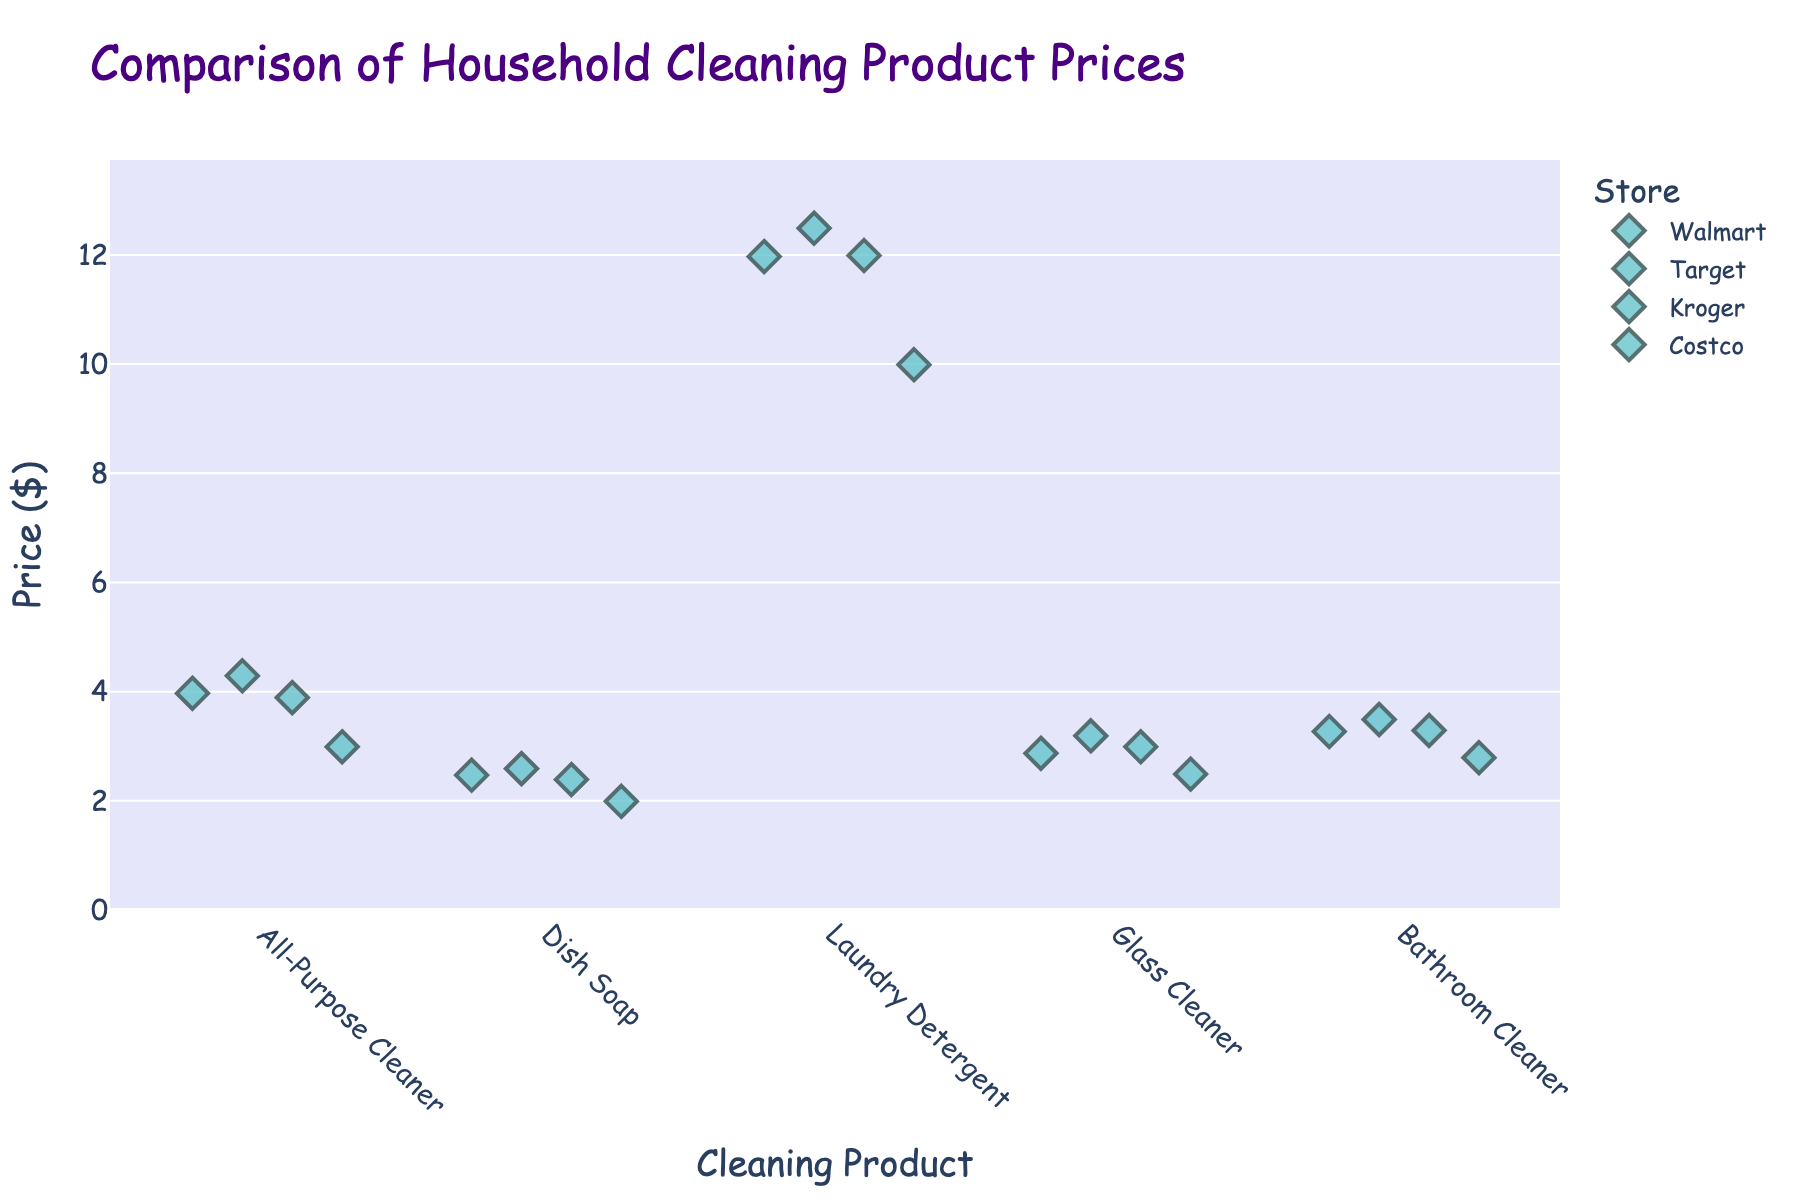How many products are compared in the figure? The X-axis of the strip plot shows different products being compared. Each unique product name corresponds to a different category on the axis. By counting them, we see there are five categories: All-Purpose Cleaner, Dish Soap, Laundry Detergent, Glass Cleaner, and Bathroom Cleaner.
Answer: 5 Which store offers the cheapest price for Laundry Detergent? To find the cheapest price for Laundry Detergent, look at the prices for Laundry Detergent across all stores. Walmart offers it at $11.97, Target at $12.49, Kroger at $11.99, and Costco at $9.99. The cheapest price is $9.99 at Costco.
Answer: Costco Which product has the highest price for any store, and what is that price? For each product, check the maximum price listed at any store. The prices for All-Purpose Cleaner range from $2.99 to $4.29, Dish Soap from $1.99 to $2.59, Laundry Detergent from $9.99 to $12.49, Glass Cleaner from $2.49 to $3.19, and Bathroom Cleaner from $2.79 to $3.49. The highest price is $12.49 for Laundry Detergent at Target.
Answer: Laundry Detergent; $12.49 What is the price range for Dish Soap across the different stores? To determine the price range, find the minimum and maximum prices for Dish Soap. The prices are $2.47 at Walmart, $2.59 at Target, $2.39 at Kroger, and $1.99 at Costco. The range is from $1.99 to $2.59, making it $2.59 - $1.99 = $0.60.
Answer: $0.60 Compare the prices for Bathroom Cleaner between Walmart and Target. Which store is more expensive and by how much? Find the prices of Bathroom Cleaner at Walmart and Target. Walmart offers it at $3.27 and Target at $3.49. The difference is $3.49 - $3.27 = $0.22. Target is more expensive by $0.22.
Answer: Target; $0.22 Which store consistently offers the cheapest prices for most products? By reviewing the prices for each product across all stores, it's evident that Costco offers the lowest prices in 4 out of 5 categories: All-Purpose Cleaner, Dish Soap, Laundry Detergent, Glass Cleaner, and Bathroom Cleaner.
Answer: Costco For those products where Costco is not the cheapest, which store offers a lower price? For All-Purpose Cleaner, Costco is the cheapest. For Dish Soap, Costco is the cheapest. For Laundry Detergent, Walmart is $11.97 (more expensive than Costco's $9.99). For Glass Cleaner, no store has a price lower than Costco’s. For Bathroom Cleaner, no store offers a cheaper price. The only exception where Costco does not have the cheapest price is Laundry Detergent at Walmart.
Answer: Walmart What is the average price of Glass Cleaner across all stores? The prices of Glass Cleaner are $2.87 at Walmart, $3.19 at Target, $2.99 at Kroger, and $2.49 at Costco. Sum these prices ($2.87 + $3.19 + $2.99 + $2.49 = $11.54) and divide by the number of stores (4). The average price is $11.54 / 4 = $2.885.
Answer: $2.885 What product demonstrates the smallest price difference across stores? Determine the price difference for each product. All-Purpose Cleaner ranges from $2.99 to $4.29 ($1.30 difference), Dish Soap from $1.99 to $2.59 ($0.60 difference), Laundry Detergent from $9.99 to $12.49 ($2.50 difference), Glass Cleaner from $2.49 to $3.19 ($0.70 difference), and Bathroom Cleaner from $2.79 to $3.49 ($0.70 difference). The smallest difference is $0.60 for Dish Soap.
Answer: Dish Soap 